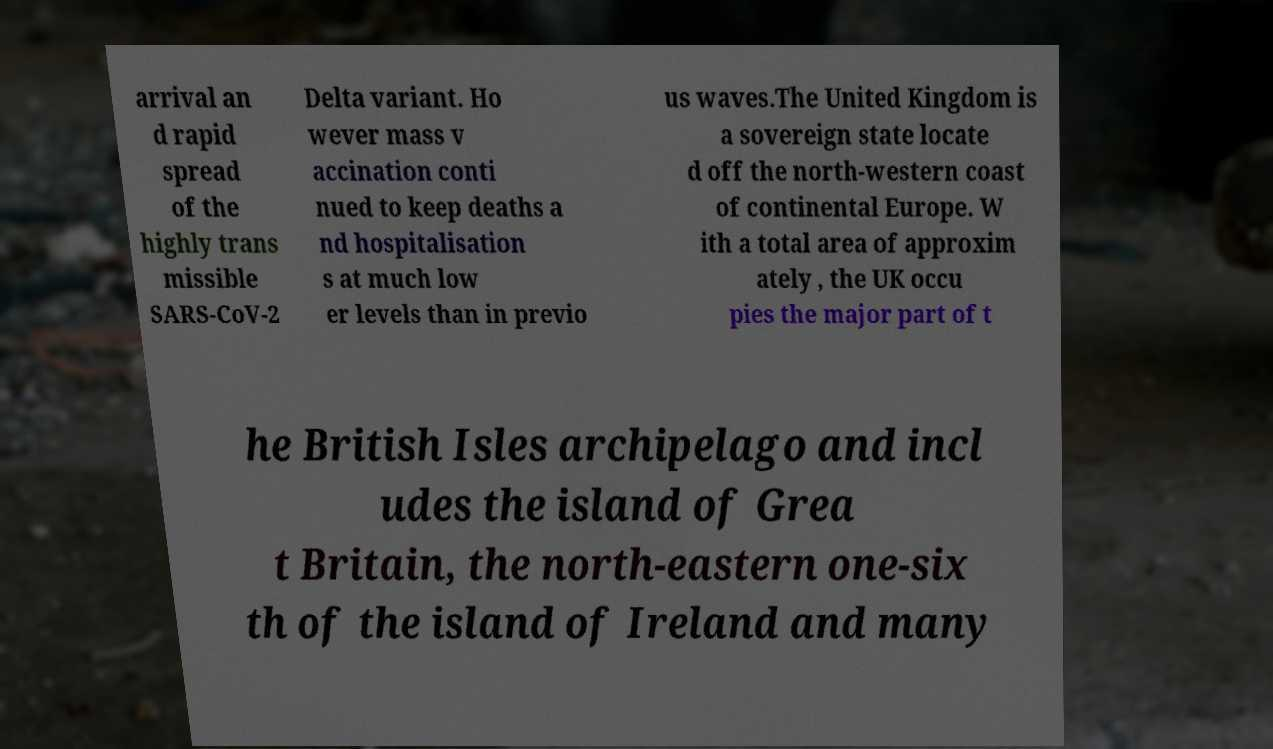Please identify and transcribe the text found in this image. arrival an d rapid spread of the highly trans missible SARS-CoV-2 Delta variant. Ho wever mass v accination conti nued to keep deaths a nd hospitalisation s at much low er levels than in previo us waves.The United Kingdom is a sovereign state locate d off the north-western coast of continental Europe. W ith a total area of approxim ately , the UK occu pies the major part of t he British Isles archipelago and incl udes the island of Grea t Britain, the north-eastern one-six th of the island of Ireland and many 